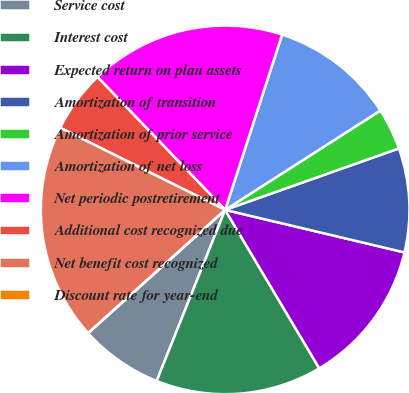<chart> <loc_0><loc_0><loc_500><loc_500><pie_chart><fcel>Service cost<fcel>Interest cost<fcel>Expected return on plan assets<fcel>Amortization of transition<fcel>Amortization of prior service<fcel>Amortization of net loss<fcel>Net periodic postretirement<fcel>Additional cost recognized due<fcel>Net benefit cost recognized<fcel>Discount rate for year-end<nl><fcel>7.29%<fcel>14.59%<fcel>12.76%<fcel>9.12%<fcel>3.65%<fcel>10.94%<fcel>17.18%<fcel>5.47%<fcel>19.0%<fcel>0.0%<nl></chart> 